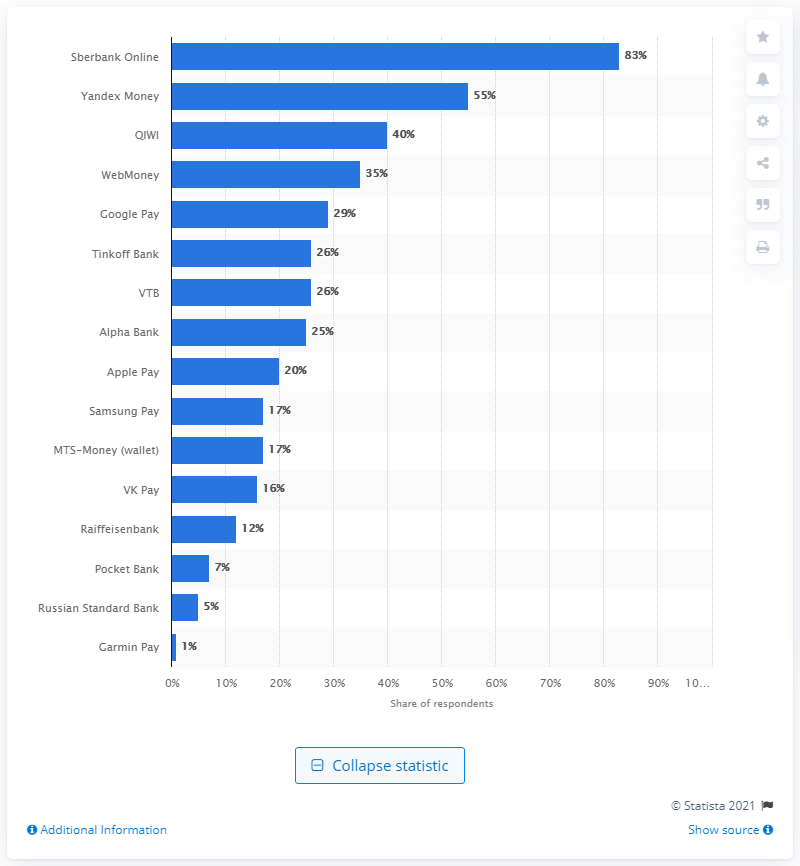Mention a couple of crucial points in this snapshot. QIWI was the third most popular payment service in Russia. In 2020, a significant 83% of Russians used Sberbank Online for their online payment needs. According to the data from 2020, Sberbank Online was the most frequently used online payment service in Russia. 